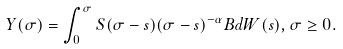Convert formula to latex. <formula><loc_0><loc_0><loc_500><loc_500>Y ( \sigma ) = \int _ { 0 } ^ { \sigma } S ( \sigma - s ) ( \sigma - s ) ^ { - \alpha } B d W ( s ) , \sigma \geq 0 .</formula> 